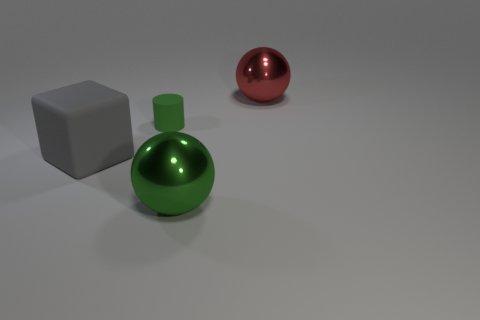What is the small cylinder made of?
Provide a succinct answer. Rubber. There is a sphere that is behind the big green sphere that is in front of the metallic ball that is behind the small object; what color is it?
Provide a succinct answer. Red. What number of balls have the same size as the gray rubber thing?
Your response must be concise. 2. The metal sphere that is behind the cylinder is what color?
Offer a terse response. Red. How many other things are the same size as the rubber cube?
Provide a succinct answer. 2. What size is the thing that is to the right of the green cylinder and behind the large gray object?
Offer a terse response. Large. Do the large rubber block and the ball behind the big green shiny sphere have the same color?
Offer a terse response. No. Is there a green matte thing that has the same shape as the gray object?
Your response must be concise. No. How many objects are large green things or things right of the tiny rubber object?
Provide a short and direct response. 2. What number of other objects are there of the same material as the tiny object?
Give a very brief answer. 1. 